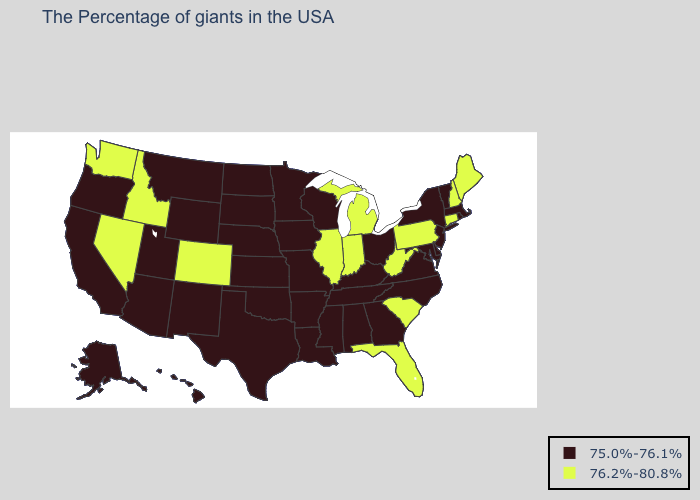What is the value of Michigan?
Concise answer only. 76.2%-80.8%. Which states have the lowest value in the USA?
Keep it brief. Massachusetts, Rhode Island, Vermont, New York, New Jersey, Delaware, Maryland, Virginia, North Carolina, Ohio, Georgia, Kentucky, Alabama, Tennessee, Wisconsin, Mississippi, Louisiana, Missouri, Arkansas, Minnesota, Iowa, Kansas, Nebraska, Oklahoma, Texas, South Dakota, North Dakota, Wyoming, New Mexico, Utah, Montana, Arizona, California, Oregon, Alaska, Hawaii. Name the states that have a value in the range 75.0%-76.1%?
Concise answer only. Massachusetts, Rhode Island, Vermont, New York, New Jersey, Delaware, Maryland, Virginia, North Carolina, Ohio, Georgia, Kentucky, Alabama, Tennessee, Wisconsin, Mississippi, Louisiana, Missouri, Arkansas, Minnesota, Iowa, Kansas, Nebraska, Oklahoma, Texas, South Dakota, North Dakota, Wyoming, New Mexico, Utah, Montana, Arizona, California, Oregon, Alaska, Hawaii. What is the highest value in the South ?
Quick response, please. 76.2%-80.8%. Among the states that border Kentucky , which have the highest value?
Keep it brief. West Virginia, Indiana, Illinois. What is the value of West Virginia?
Concise answer only. 76.2%-80.8%. Among the states that border Maryland , which have the highest value?
Write a very short answer. Pennsylvania, West Virginia. What is the value of Texas?
Keep it brief. 75.0%-76.1%. Does the map have missing data?
Concise answer only. No. Which states hav the highest value in the South?
Short answer required. South Carolina, West Virginia, Florida. Does Mississippi have the same value as Kentucky?
Write a very short answer. Yes. Does Indiana have the lowest value in the MidWest?
Be succinct. No. Does the first symbol in the legend represent the smallest category?
Be succinct. Yes. Name the states that have a value in the range 75.0%-76.1%?
Write a very short answer. Massachusetts, Rhode Island, Vermont, New York, New Jersey, Delaware, Maryland, Virginia, North Carolina, Ohio, Georgia, Kentucky, Alabama, Tennessee, Wisconsin, Mississippi, Louisiana, Missouri, Arkansas, Minnesota, Iowa, Kansas, Nebraska, Oklahoma, Texas, South Dakota, North Dakota, Wyoming, New Mexico, Utah, Montana, Arizona, California, Oregon, Alaska, Hawaii. 